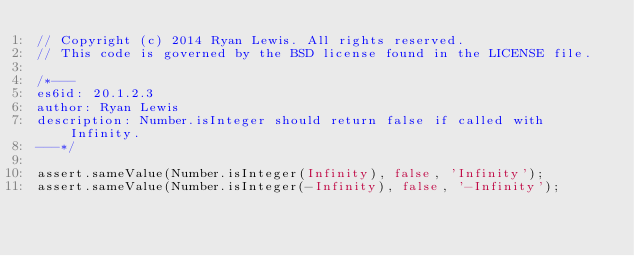Convert code to text. <code><loc_0><loc_0><loc_500><loc_500><_JavaScript_>// Copyright (c) 2014 Ryan Lewis. All rights reserved.
// This code is governed by the BSD license found in the LICENSE file.

/*---
es6id: 20.1.2.3
author: Ryan Lewis
description: Number.isInteger should return false if called with Infinity.
---*/

assert.sameValue(Number.isInteger(Infinity), false, 'Infinity');
assert.sameValue(Number.isInteger(-Infinity), false, '-Infinity');
</code> 